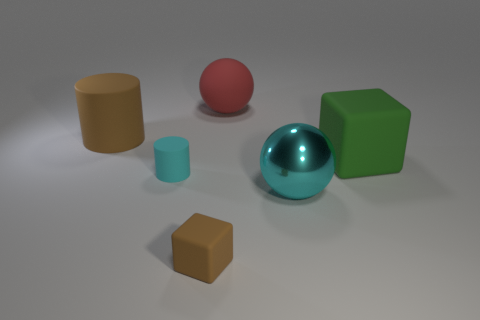Add 2 matte objects. How many objects exist? 8 Subtract all cyan spheres. How many spheres are left? 1 Subtract all spheres. How many objects are left? 4 Subtract 2 spheres. How many spheres are left? 0 Subtract all blue spheres. Subtract all blue cubes. How many spheres are left? 2 Subtract all gray cylinders. How many green cubes are left? 1 Subtract all large brown cubes. Subtract all matte blocks. How many objects are left? 4 Add 2 big cylinders. How many big cylinders are left? 3 Add 2 gray metal cylinders. How many gray metal cylinders exist? 2 Subtract 0 yellow balls. How many objects are left? 6 